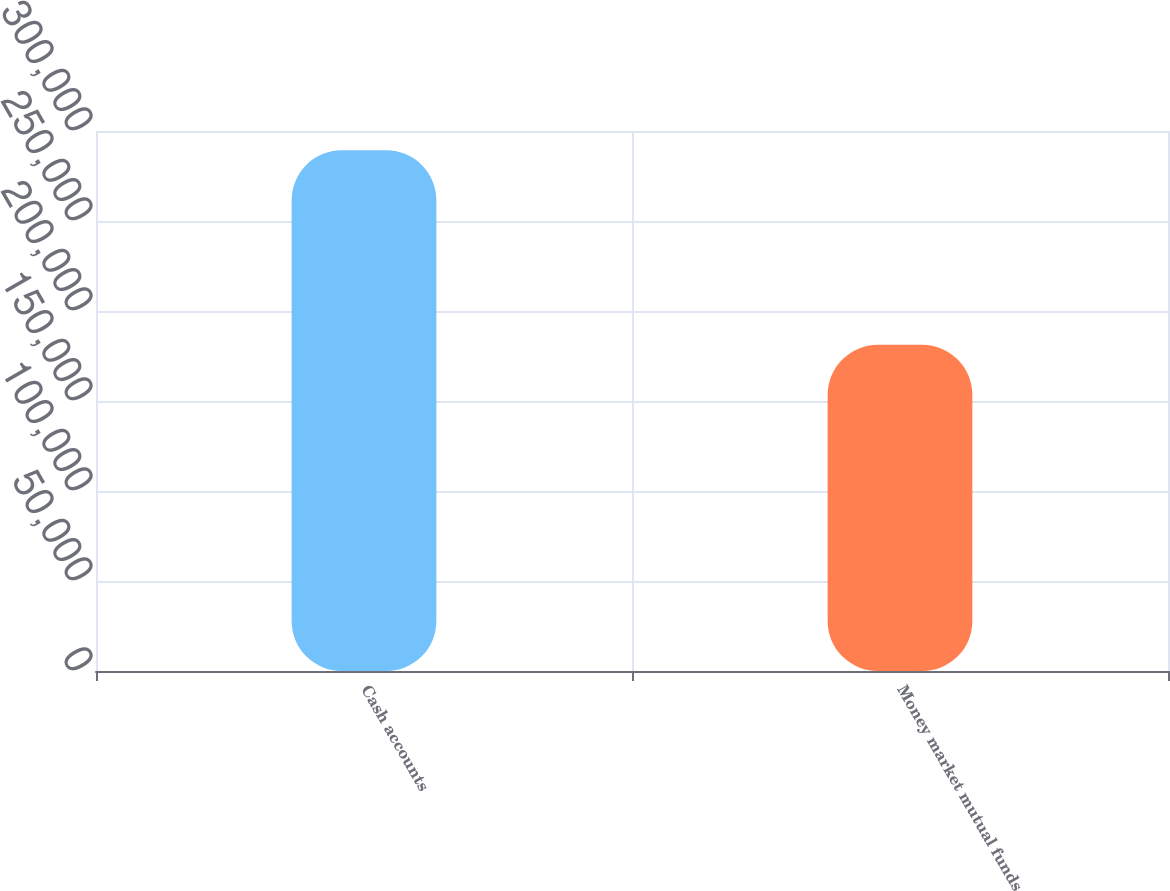<chart> <loc_0><loc_0><loc_500><loc_500><bar_chart><fcel>Cash accounts<fcel>Money market mutual funds<nl><fcel>289298<fcel>181198<nl></chart> 